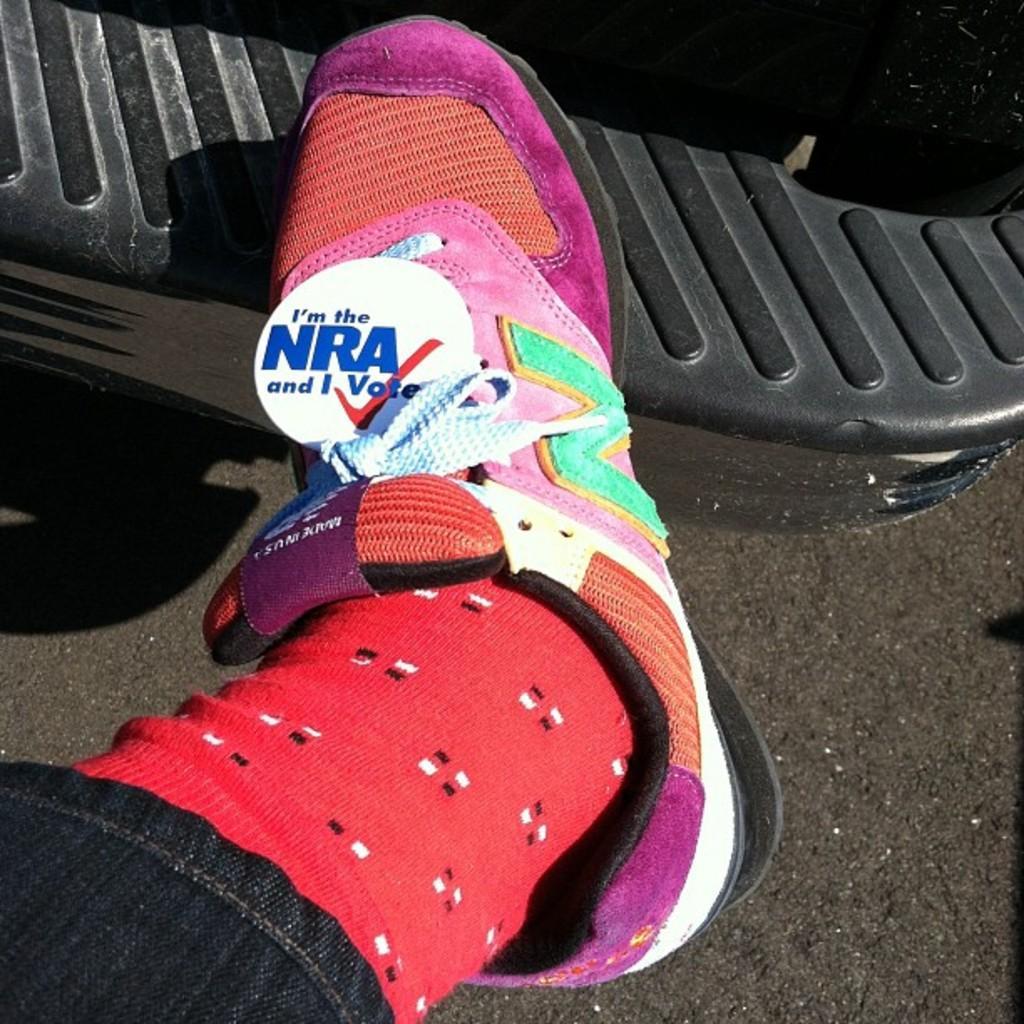Could you give a brief overview of what you see in this image? A person is wearing a shoe and red socks. 